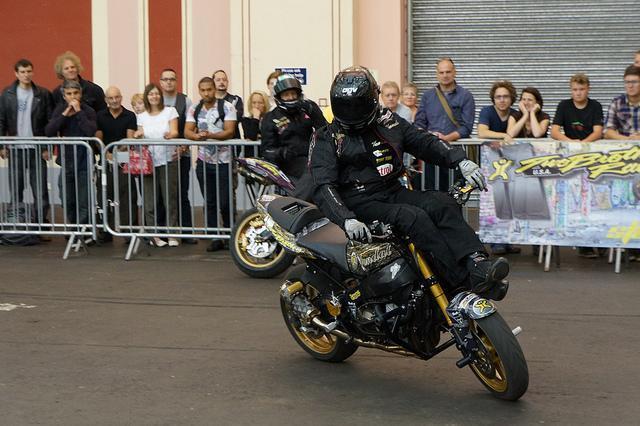How many people are on this bike?
Give a very brief answer. 1. How many people have bikes?
Give a very brief answer. 2. How many people can be seen?
Give a very brief answer. 8. How many motorcycles are there?
Give a very brief answer. 2. How many blue cars are in the picture?
Give a very brief answer. 0. 